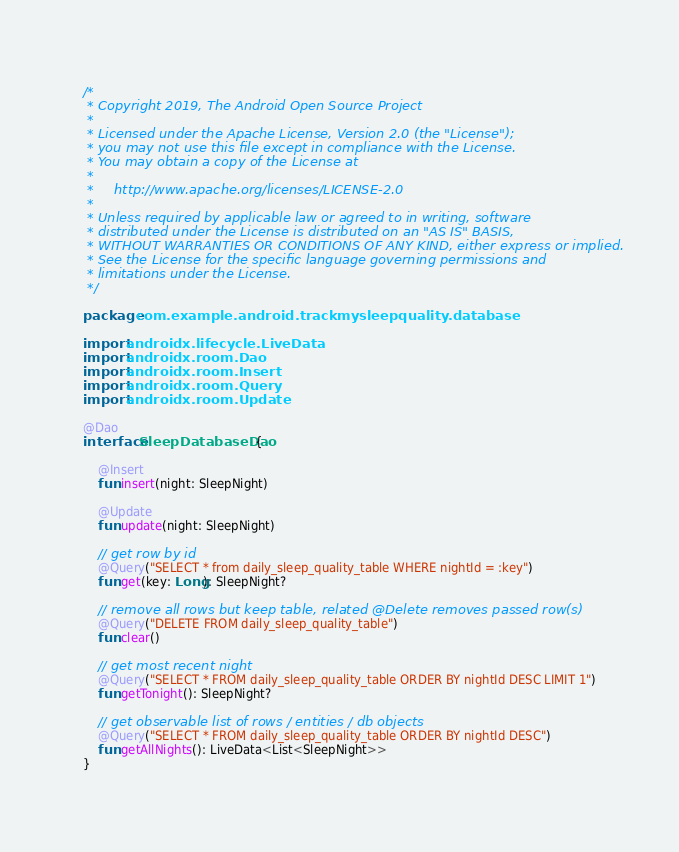<code> <loc_0><loc_0><loc_500><loc_500><_Kotlin_>/*
 * Copyright 2019, The Android Open Source Project
 *
 * Licensed under the Apache License, Version 2.0 (the "License");
 * you may not use this file except in compliance with the License.
 * You may obtain a copy of the License at
 *
 *     http://www.apache.org/licenses/LICENSE-2.0
 *
 * Unless required by applicable law or agreed to in writing, software
 * distributed under the License is distributed on an "AS IS" BASIS,
 * WITHOUT WARRANTIES OR CONDITIONS OF ANY KIND, either express or implied.
 * See the License for the specific language governing permissions and
 * limitations under the License.
 */

package com.example.android.trackmysleepquality.database

import androidx.lifecycle.LiveData
import androidx.room.Dao
import androidx.room.Insert
import androidx.room.Query
import androidx.room.Update

@Dao
interface SleepDatabaseDao {

    @Insert
    fun insert(night: SleepNight)

    @Update
    fun update(night: SleepNight)

    // get row by id
    @Query("SELECT * from daily_sleep_quality_table WHERE nightId = :key")
    fun get(key: Long): SleepNight?

    // remove all rows but keep table, related @Delete removes passed row(s)
    @Query("DELETE FROM daily_sleep_quality_table")
    fun clear()

    // get most recent night
    @Query("SELECT * FROM daily_sleep_quality_table ORDER BY nightId DESC LIMIT 1")
    fun getTonight(): SleepNight?

    // get observable list of rows / entities / db objects
    @Query("SELECT * FROM daily_sleep_quality_table ORDER BY nightId DESC")
    fun getAllNights(): LiveData<List<SleepNight>>
}
</code> 